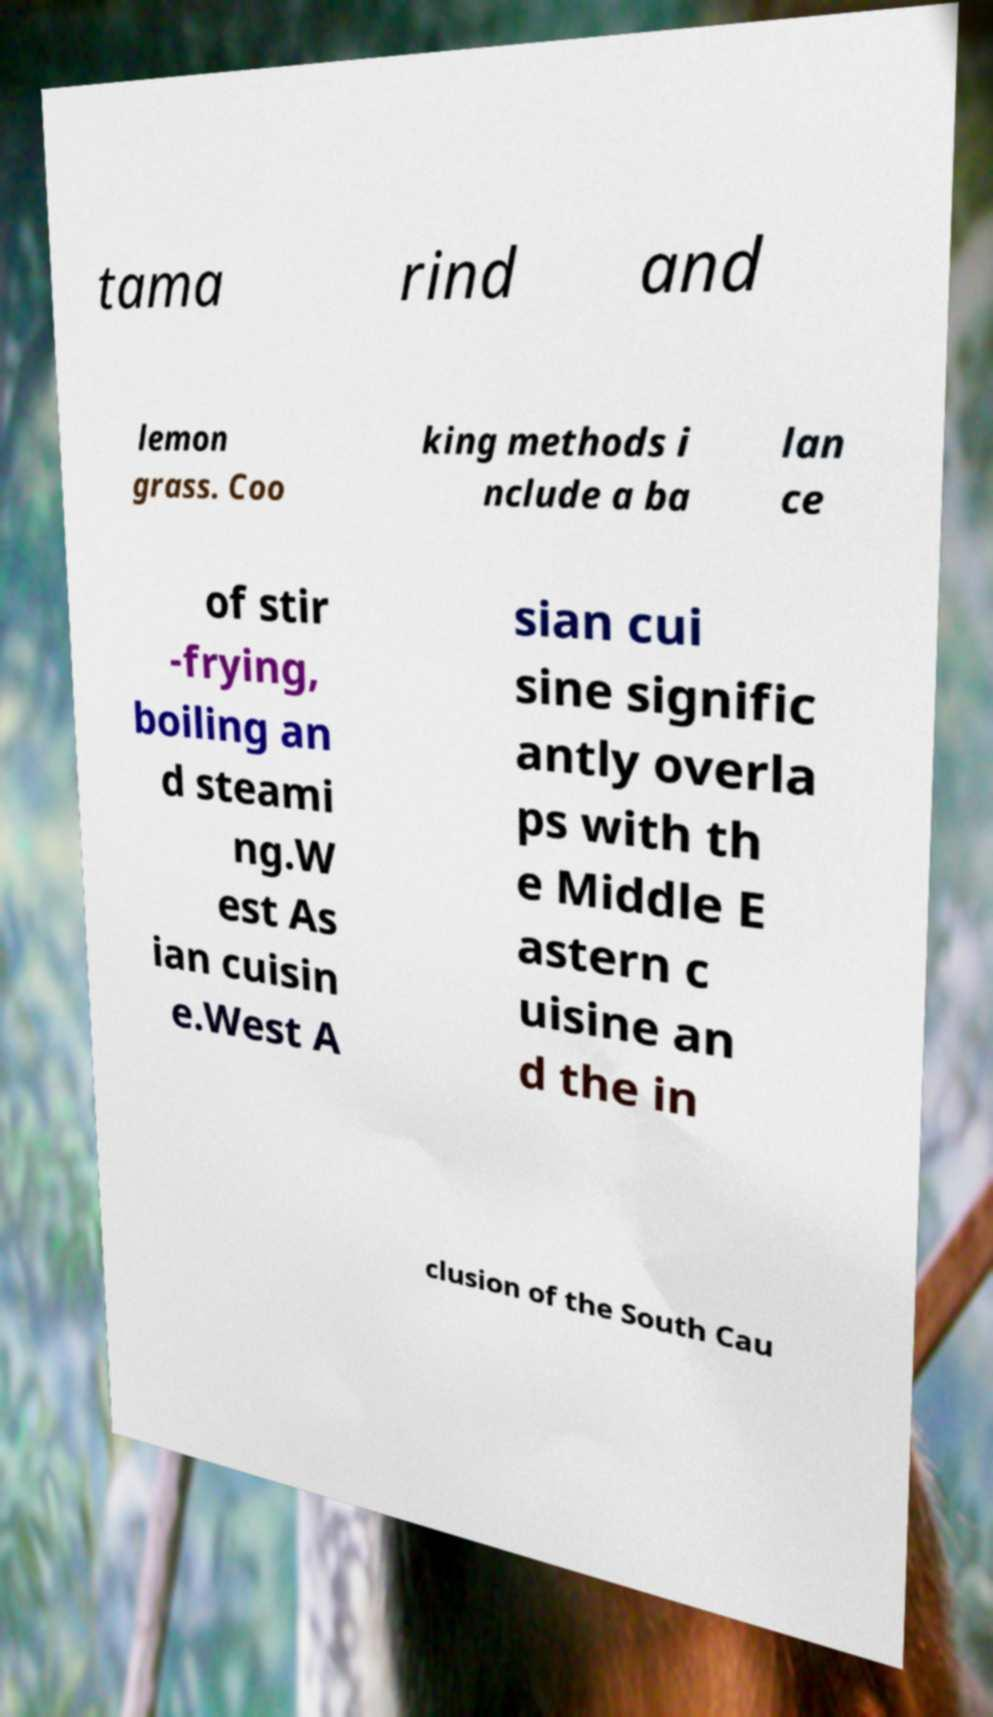For documentation purposes, I need the text within this image transcribed. Could you provide that? tama rind and lemon grass. Coo king methods i nclude a ba lan ce of stir -frying, boiling an d steami ng.W est As ian cuisin e.West A sian cui sine signific antly overla ps with th e Middle E astern c uisine an d the in clusion of the South Cau 